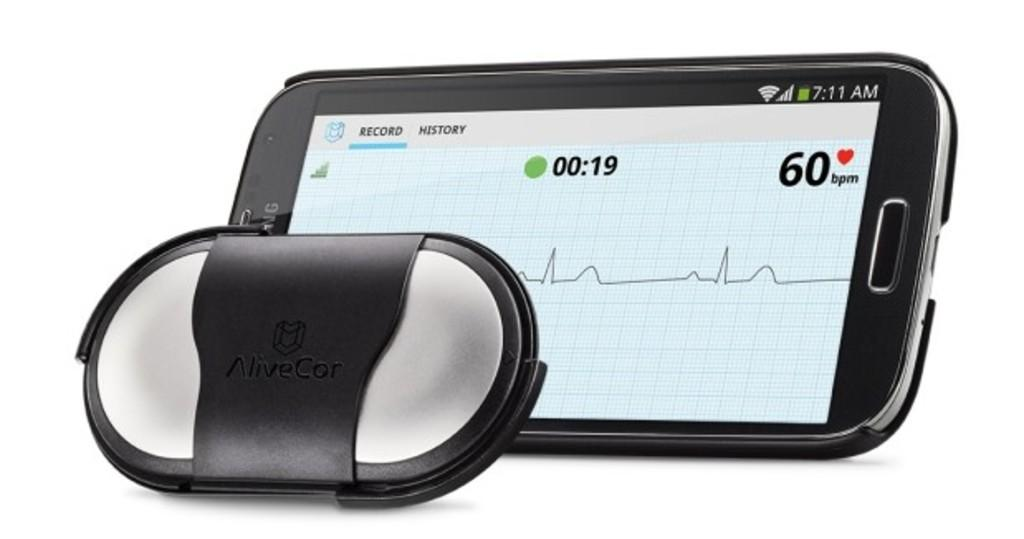<image>
Share a concise interpretation of the image provided. the number 60 is on the phone with a heart next to it 